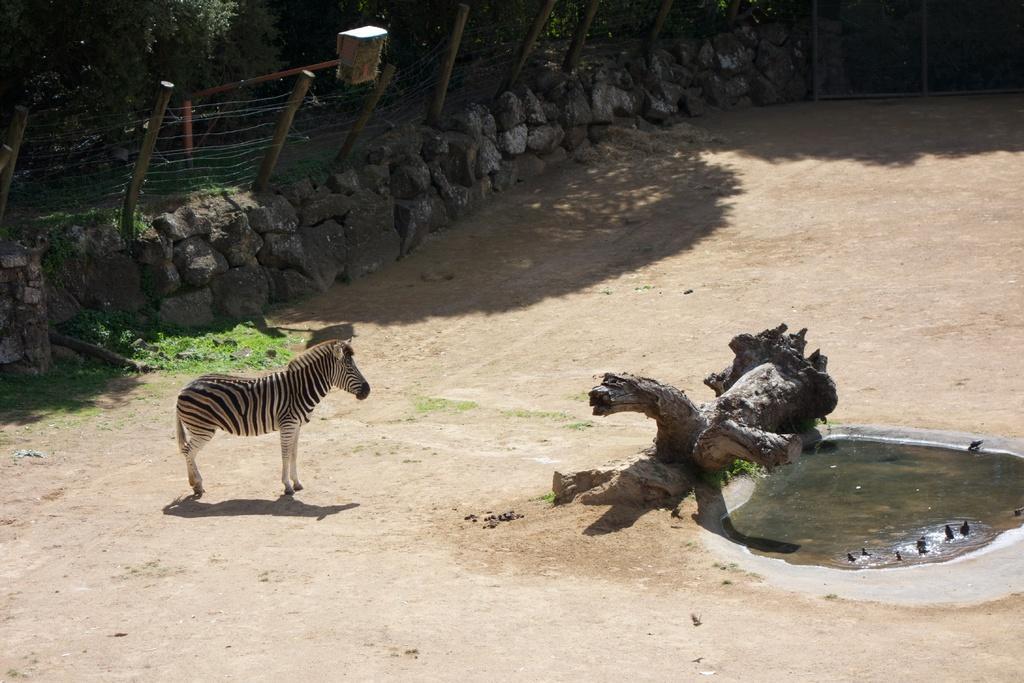Could you give a brief overview of what you see in this image? In this picture I can see a Zebra and tree bark and a small water pond and a metal fence around and few rocks and trees and looks like few birds in the water. 